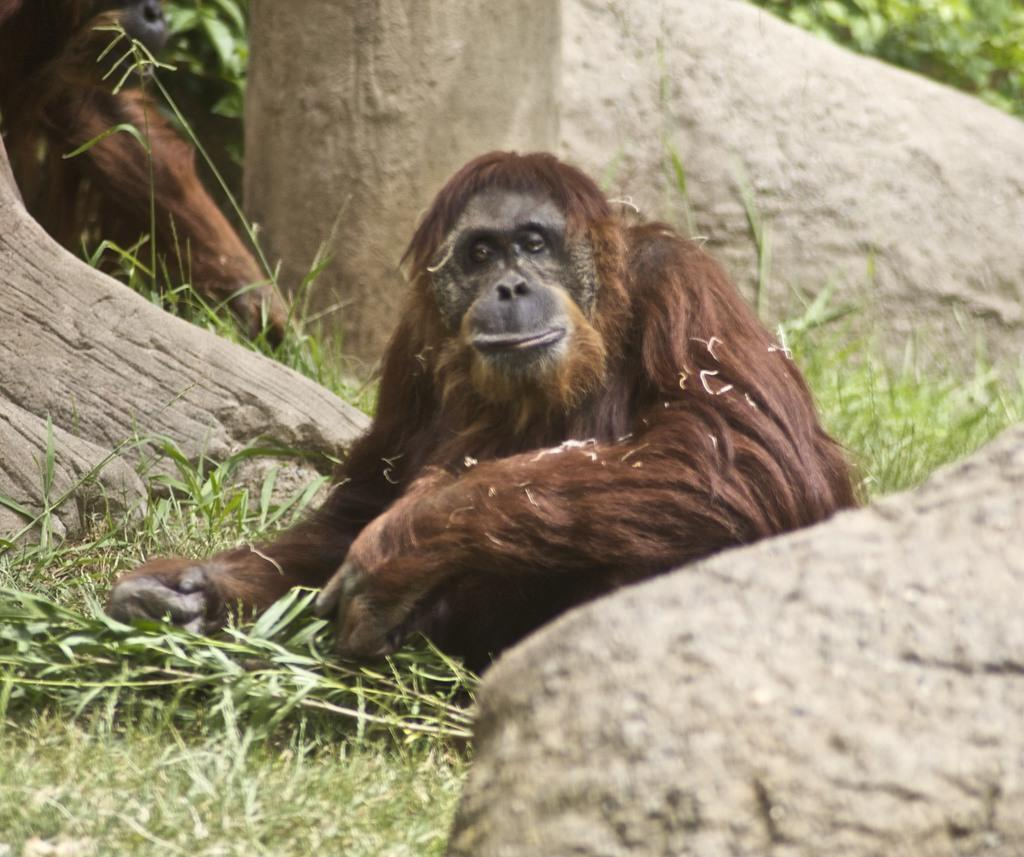What types of living organisms can be seen in the image? There are animals in the image. What type of vegetation is present in the image? There is grass in the image. What other natural elements can be seen in the image? There are rocks in the image. How many hens are visible in the image? There is no hen present in the image; only animals, grass, and rocks are visible. Can you tell me how many mice are hiding under the rocks in the image? There is no indication of mice in the image; only animals, grass, and rocks are visible. 